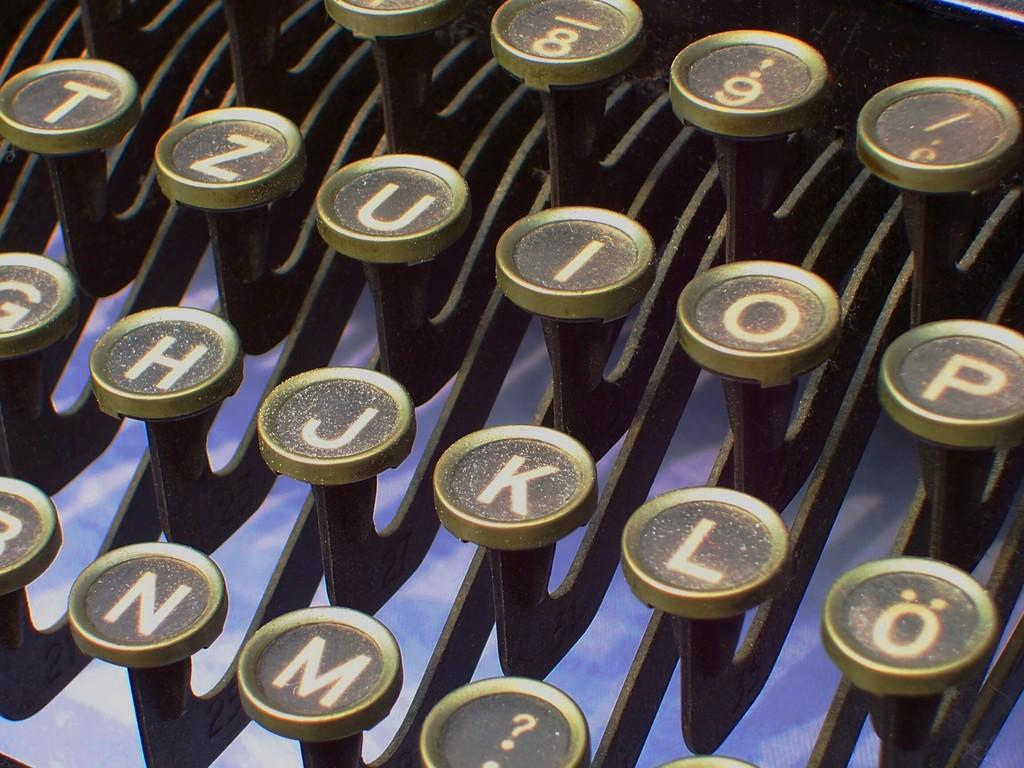What objects are visible in the image? Typewriter keys are visible in the image. What might these typewriter keys be used for? The typewriter keys are likely used for typing on a typewriter. Can you describe the appearance of the typewriter keys? The typewriter keys are visible and distinct in the image. How does the muscle development of the person in the image compare to that of a professional athlete? There is no person visible in the image, and therefore no muscle development can be observed or compared. 